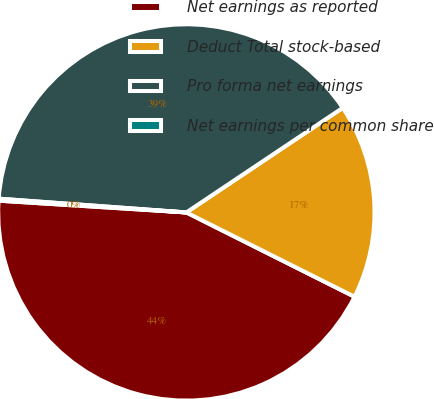<chart> <loc_0><loc_0><loc_500><loc_500><pie_chart><fcel>Net earnings as reported<fcel>Deduct Total stock-based<fcel>Pro forma net earnings<fcel>Net earnings per common share<nl><fcel>43.6%<fcel>16.78%<fcel>39.45%<fcel>0.17%<nl></chart> 